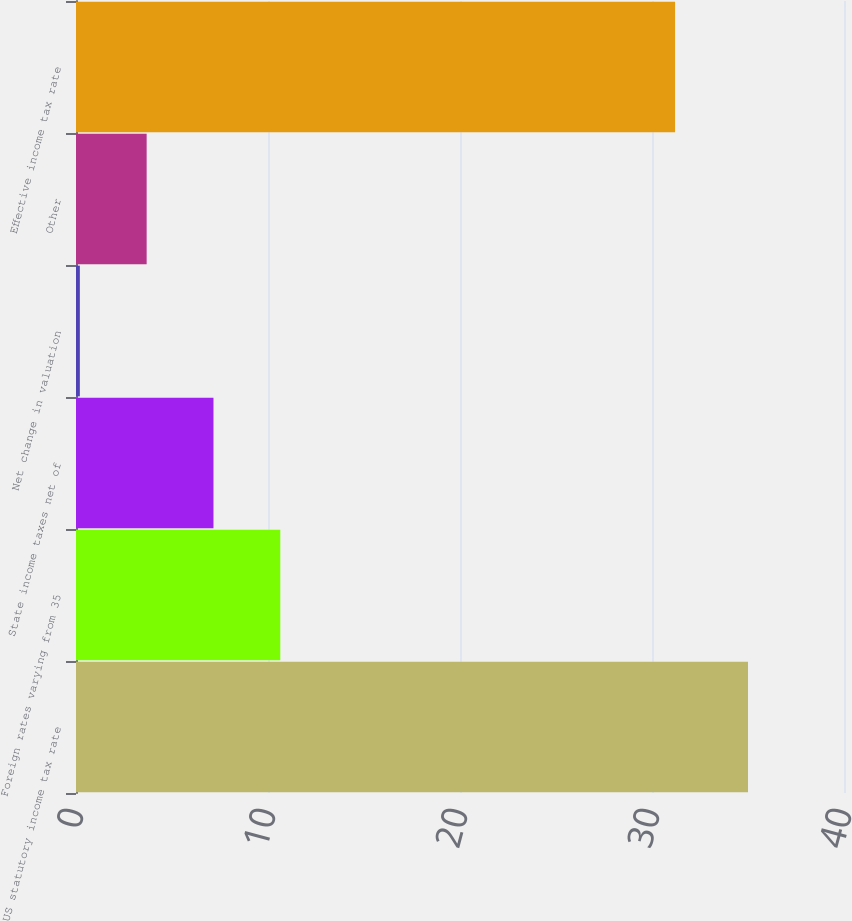Convert chart. <chart><loc_0><loc_0><loc_500><loc_500><bar_chart><fcel>US statutory income tax rate<fcel>Foreign rates varying from 35<fcel>State income taxes net of<fcel>Net change in valuation<fcel>Other<fcel>Effective income tax rate<nl><fcel>35<fcel>10.64<fcel>7.16<fcel>0.2<fcel>3.68<fcel>31.2<nl></chart> 